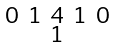Convert formula to latex. <formula><loc_0><loc_0><loc_500><loc_500>\begin{smallmatrix} 0 & 1 & 4 & 1 & 0 \\ & & 1 & & \end{smallmatrix}</formula> 